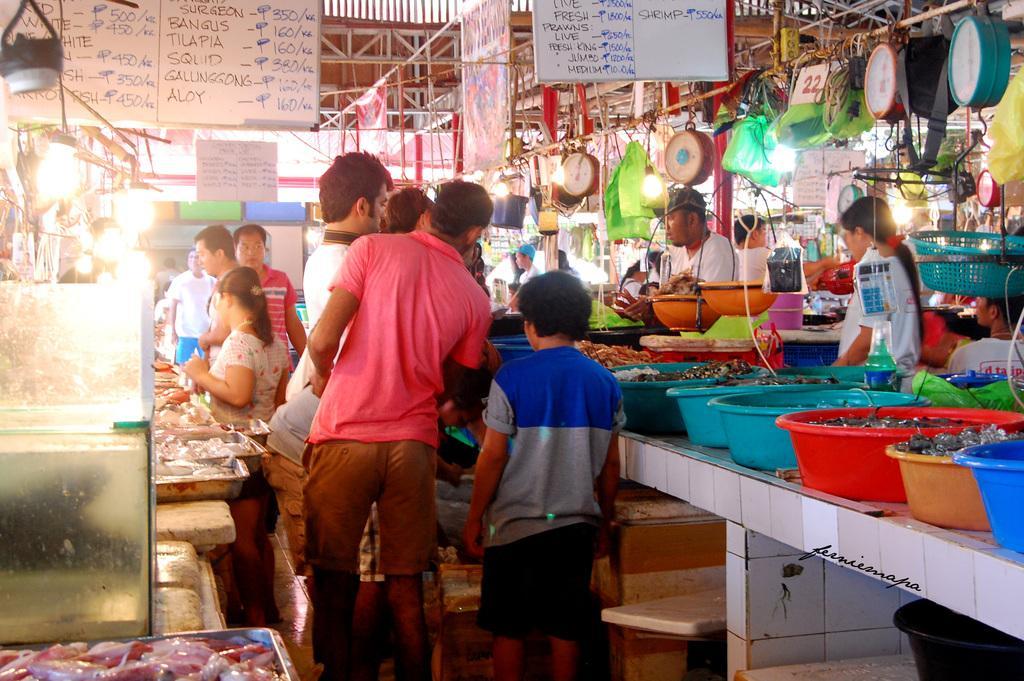How would you summarize this image in a sentence or two? In this image there are tables. On top of it there are tubs. Inside the tubs there are a few objects. On the right side of the image there are clocks and a few other objects hanging from the metal rod. There are people standing beside the tables. There are boards with some text on it. There are banners. There are lights. 